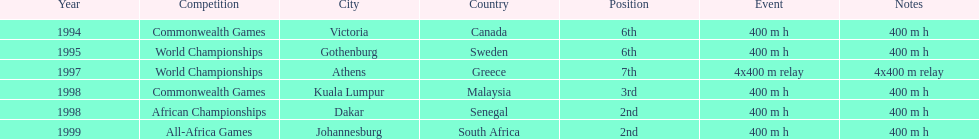What was the venue before dakar, senegal? Kuala Lumpur, Malaysia. 